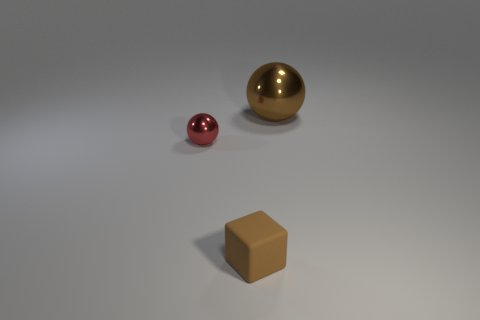Add 2 tiny blue cylinders. How many objects exist? 5 Subtract all spheres. How many objects are left? 1 Add 1 big things. How many big things are left? 2 Add 2 big brown blocks. How many big brown blocks exist? 2 Subtract 0 purple cylinders. How many objects are left? 3 Subtract all purple metal cylinders. Subtract all brown things. How many objects are left? 1 